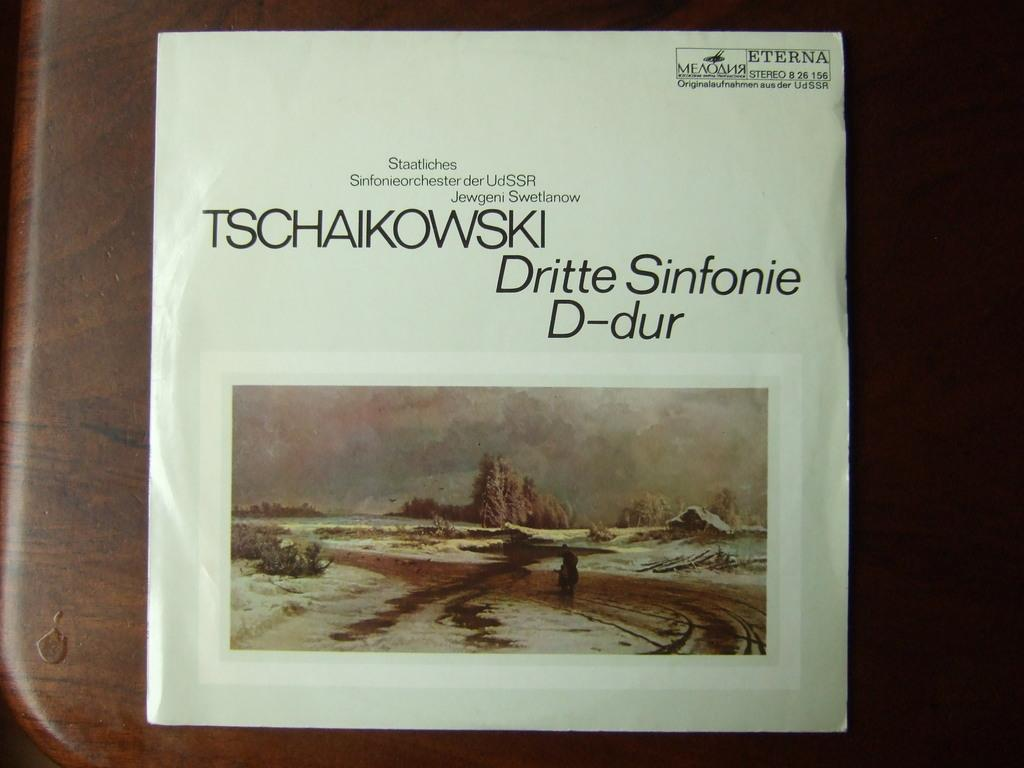<image>
Present a compact description of the photo's key features. A poster says Tschaikowski Dritte Sinfonie and shows a landscape. 